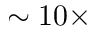Convert formula to latex. <formula><loc_0><loc_0><loc_500><loc_500>\sim 1 0 \times</formula> 